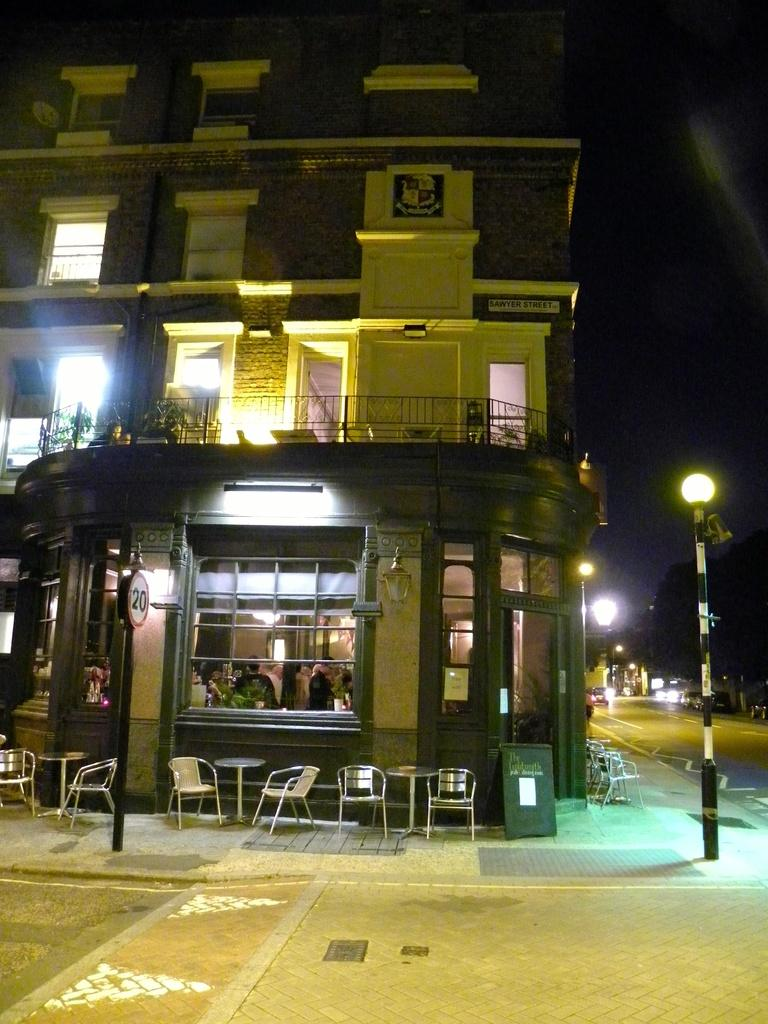What type of structure is visible in the image? There is a building in the image. What feature can be seen on the building? The building has windows. What can be observed inside the building? There are people sitting inside the building. What object is present in the image that might be used for displaying information or announcements? There is a board in the image. What type of furniture is visible in the image? There are chairs and a table in the image. What is located near the building in the image? There is a street pole in the image. What mode of transportation can be seen on the road in the image? There are cars on the road in the image. What type of natural element is present in the image? There is a tree in the image. How many pies are being served on the table in the image? There are no pies present in the image; the table has chairs around it. What type of game are the people playing inside the building? There is no indication of a game being played in the image; the people are sitting inside the building. 